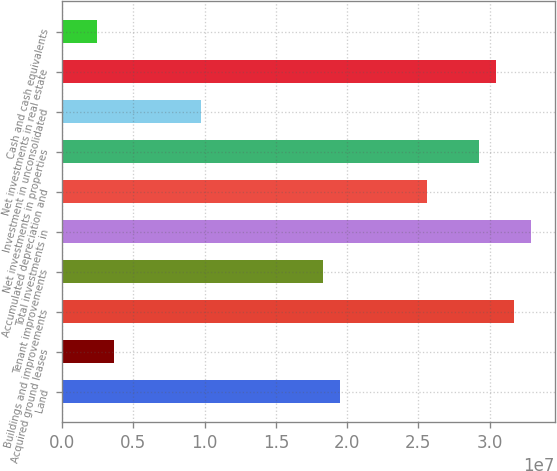<chart> <loc_0><loc_0><loc_500><loc_500><bar_chart><fcel>Land<fcel>Acquired ground leases<fcel>Buildings and improvements<fcel>Tenant improvements<fcel>Total investments in<fcel>Accumulated depreciation and<fcel>Net investments in properties<fcel>Investment in unconsolidated<fcel>Net investments in real estate<fcel>Cash and cash equivalents<nl><fcel>1.95066e+07<fcel>3.65959e+06<fcel>3.16966e+07<fcel>1.82876e+07<fcel>3.29156e+07<fcel>2.56016e+07<fcel>2.92586e+07<fcel>9.75459e+06<fcel>3.04776e+07<fcel>2.4406e+06<nl></chart> 